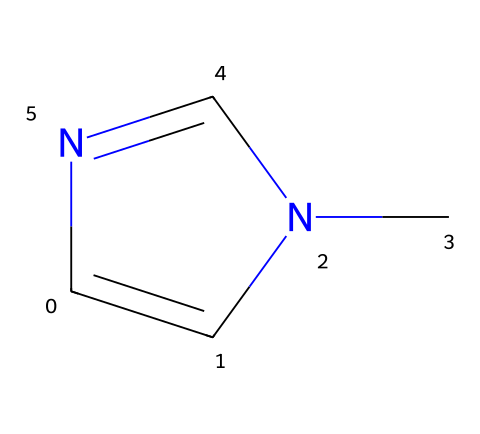How many nitrogen atoms are present in this chemical? By analyzing the SMILES representation, we can see "N" appears twice, indicating there are two nitrogen atoms in the structure.
Answer: 2 What is the total number of carbon atoms in the compound? In the SMILES string, "C" is listed twice and "N(C)" indicates a carbon atom is connected to a nitrogen, which confirms there are three carbon atoms, as one is a substituent.
Answer: 3 What is the general class of this compound? The presence of a nitrogen double bond and the overall structure indicates that this compound is a carbene, characterized by a divalent carbon atom that acts as a reactive site.
Answer: carbene Is the compound considered stable under normal conditions? Generally, carbenes are known to be highly reactive and unstable under normal conditions, which impacts their use.
Answer: no Which type of bonds connect the nitrogen atoms in the structure? Looking at the SMILES, the connection between the nitrogen atoms includes a double bond, which is characteristic of imines and related compounds.
Answer: double bonds What functional groups can be identified in this molecule? The structure contains a nitrogen double bond and a carbon, leading to the identification of an imine functional group due to the C=N bond present.
Answer: imine What would be the potential application of this compound in fuel stabilizers? Carbenes can act as intermediates or stabilizers; the reactivity of the carbene might help in preventing degradation of fuel during storage by stabilizing radicals.
Answer: stabilizing radicals 